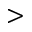Convert formula to latex. <formula><loc_0><loc_0><loc_500><loc_500>></formula> 